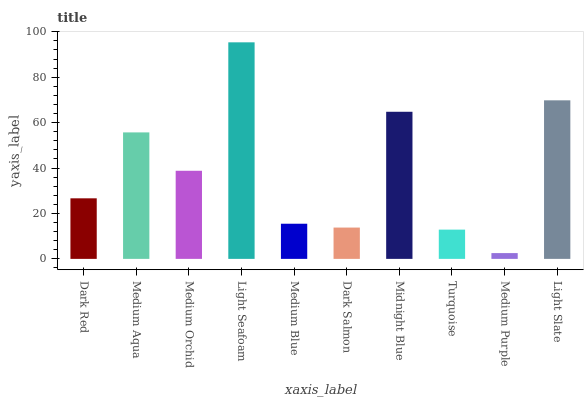Is Medium Purple the minimum?
Answer yes or no. Yes. Is Light Seafoam the maximum?
Answer yes or no. Yes. Is Medium Aqua the minimum?
Answer yes or no. No. Is Medium Aqua the maximum?
Answer yes or no. No. Is Medium Aqua greater than Dark Red?
Answer yes or no. Yes. Is Dark Red less than Medium Aqua?
Answer yes or no. Yes. Is Dark Red greater than Medium Aqua?
Answer yes or no. No. Is Medium Aqua less than Dark Red?
Answer yes or no. No. Is Medium Orchid the high median?
Answer yes or no. Yes. Is Dark Red the low median?
Answer yes or no. Yes. Is Light Seafoam the high median?
Answer yes or no. No. Is Medium Orchid the low median?
Answer yes or no. No. 